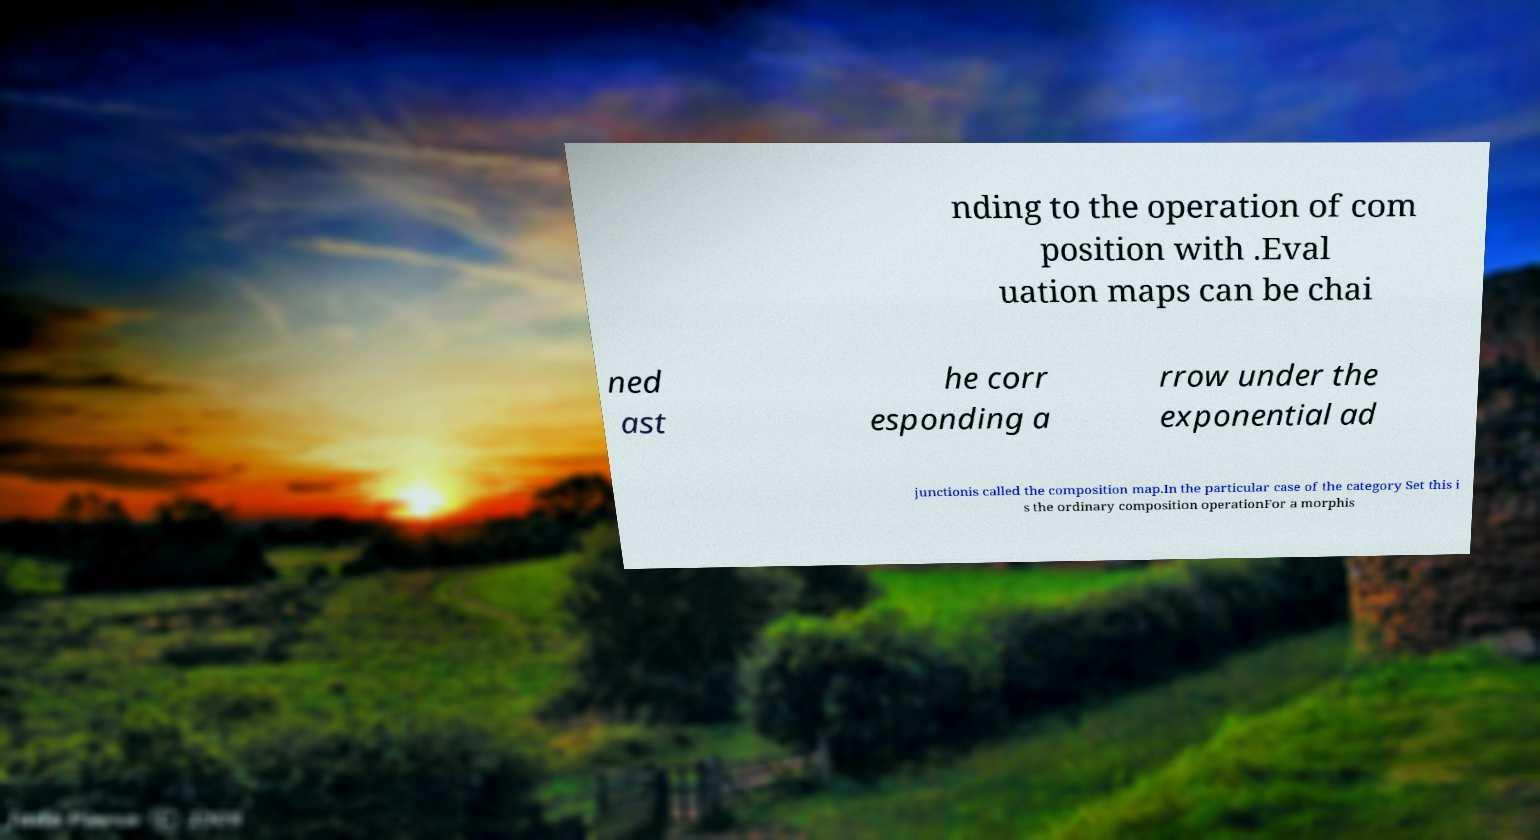For documentation purposes, I need the text within this image transcribed. Could you provide that? nding to the operation of com position with .Eval uation maps can be chai ned ast he corr esponding a rrow under the exponential ad junctionis called the composition map.In the particular case of the category Set this i s the ordinary composition operationFor a morphis 